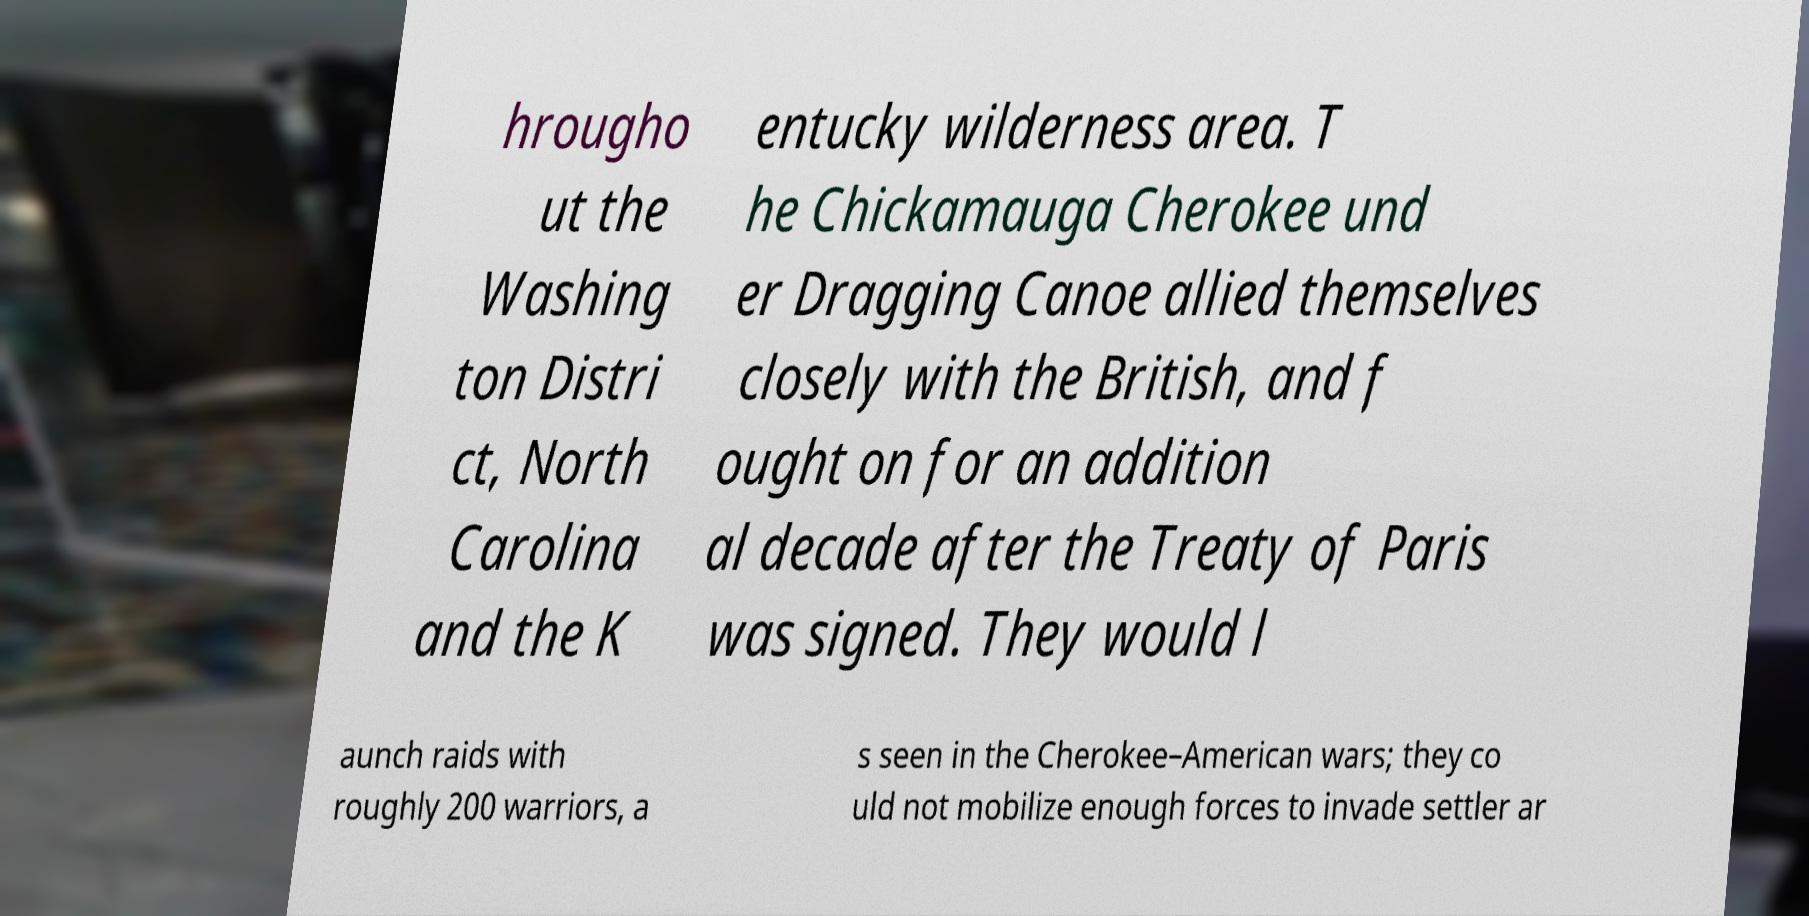There's text embedded in this image that I need extracted. Can you transcribe it verbatim? hrougho ut the Washing ton Distri ct, North Carolina and the K entucky wilderness area. T he Chickamauga Cherokee und er Dragging Canoe allied themselves closely with the British, and f ought on for an addition al decade after the Treaty of Paris was signed. They would l aunch raids with roughly 200 warriors, a s seen in the Cherokee–American wars; they co uld not mobilize enough forces to invade settler ar 